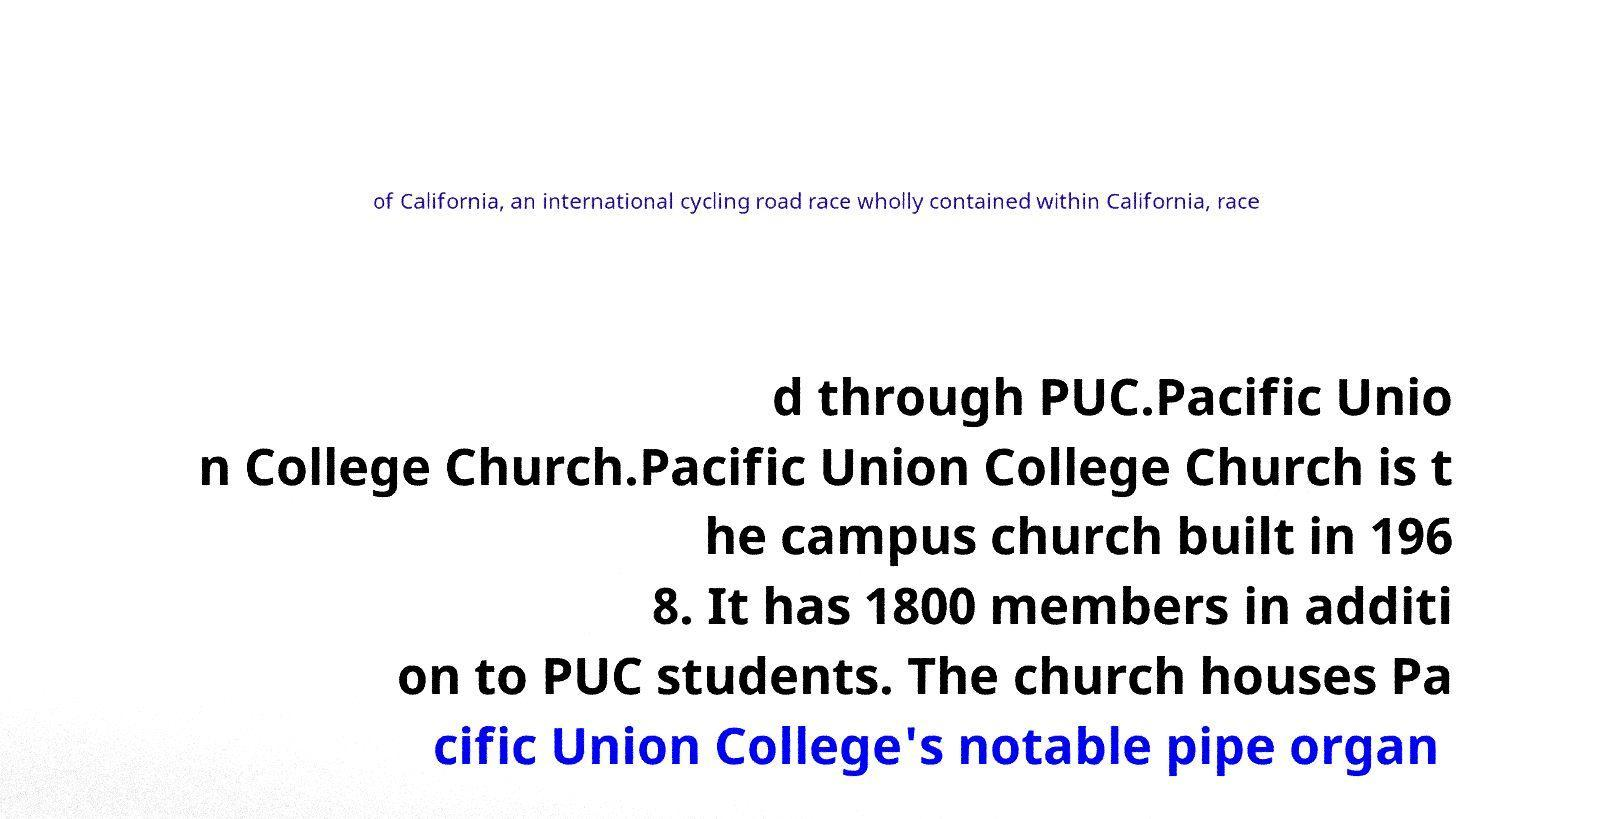Please identify and transcribe the text found in this image. of California, an international cycling road race wholly contained within California, race d through PUC.Pacific Unio n College Church.Pacific Union College Church is t he campus church built in 196 8. It has 1800 members in additi on to PUC students. The church houses Pa cific Union College's notable pipe organ 